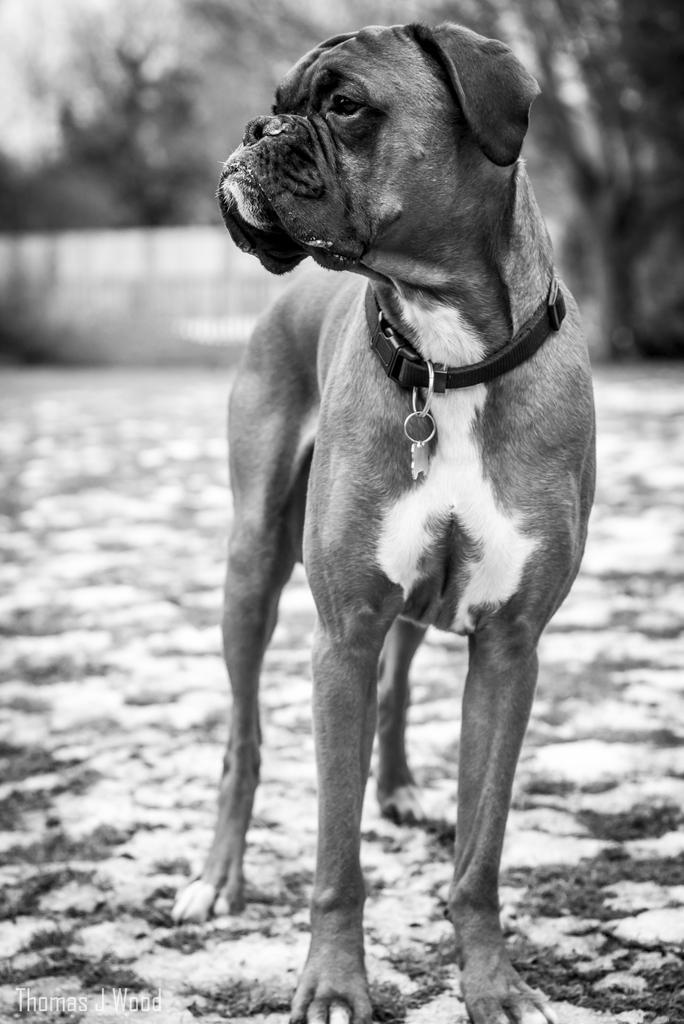In one or two sentences, can you explain what this image depicts? In this picture, we can see a dog on the floor, and the blurred background. 